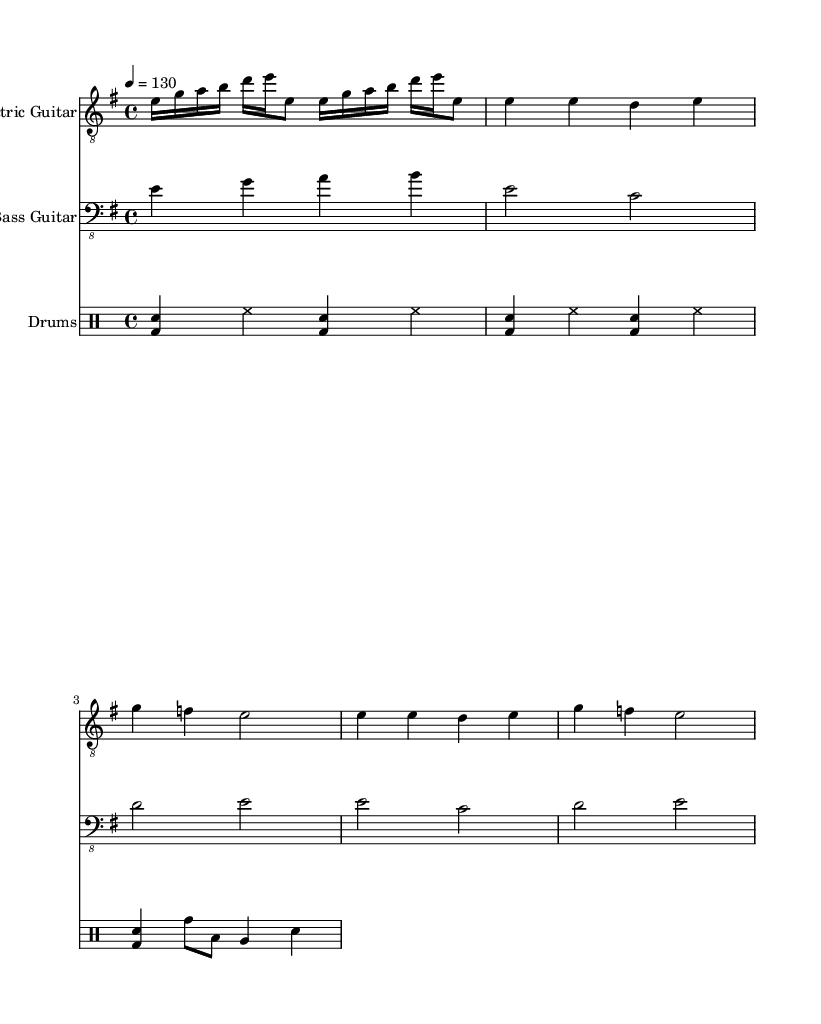What is the key signature of this music? The key signature shown in the music is E minor, which has one sharp (F#).
Answer: E minor What is the time signature of this music? The time signature is 4/4, indicating four beats per measure.
Answer: 4/4 What is the tempo marking of the piece? The tempo marking indicates a speed of 130 beats per minute, specified in the music.
Answer: 130 How many measures are present in the intro/riff section for the electric guitar? The intro/riff section repeats twice, and contains two measures for each repeat, totaling four measures.
Answer: 4 What is the primary instrument used for the melody in this arrangement? The primary instrument that plays the melody is the electric guitar, as indicated at the beginning of the staff.
Answer: Electric Guitar Identify the rhythm pattern established in the drums part during the introduction. The drums part establishes a basic rock beat with alternating bass drum and snare hits alongside hi-hat crashes.
Answer: Basic rock beat What is the relationship between the verse and chorus sections in this sheet music? The verse and chorus sections are similar in structure, both using the same rhythmic pattern and some pitch repetition but contrasting in melodic emphasis.
Answer: Similar 